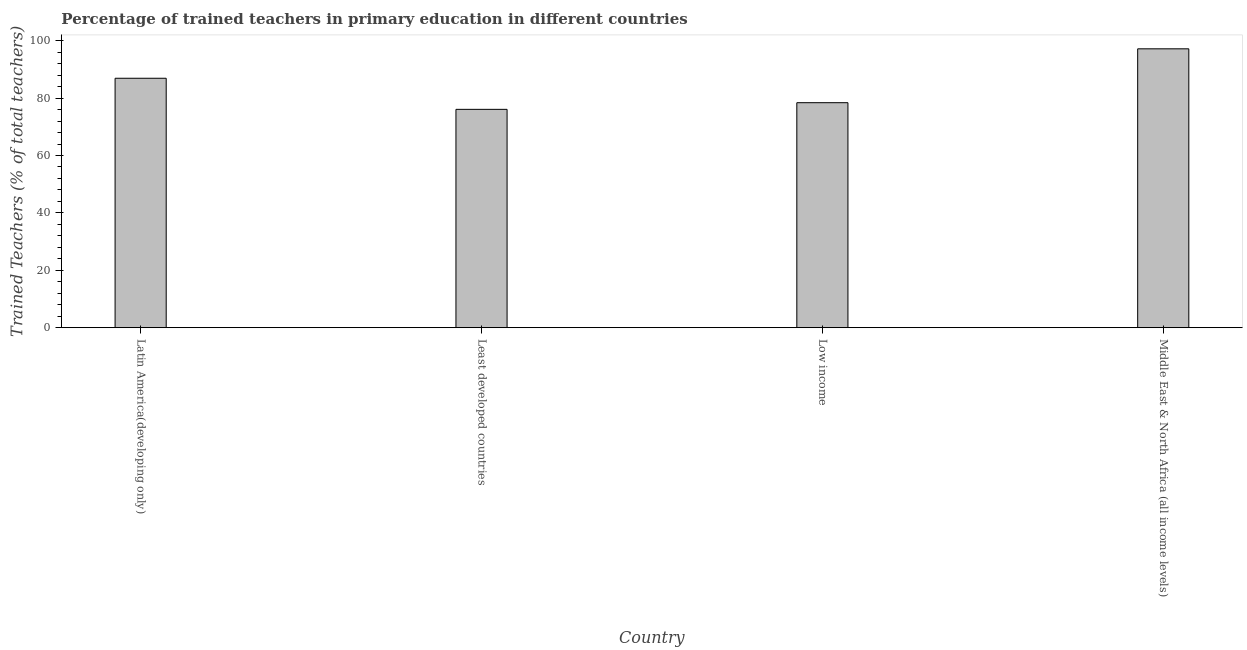Does the graph contain grids?
Offer a terse response. No. What is the title of the graph?
Your response must be concise. Percentage of trained teachers in primary education in different countries. What is the label or title of the Y-axis?
Your answer should be very brief. Trained Teachers (% of total teachers). What is the percentage of trained teachers in Latin America(developing only)?
Make the answer very short. 86.92. Across all countries, what is the maximum percentage of trained teachers?
Your answer should be very brief. 97.18. Across all countries, what is the minimum percentage of trained teachers?
Your response must be concise. 76.09. In which country was the percentage of trained teachers maximum?
Offer a terse response. Middle East & North Africa (all income levels). In which country was the percentage of trained teachers minimum?
Your answer should be very brief. Least developed countries. What is the sum of the percentage of trained teachers?
Your answer should be compact. 338.6. What is the difference between the percentage of trained teachers in Latin America(developing only) and Least developed countries?
Offer a very short reply. 10.84. What is the average percentage of trained teachers per country?
Offer a terse response. 84.65. What is the median percentage of trained teachers?
Provide a succinct answer. 82.66. In how many countries, is the percentage of trained teachers greater than 32 %?
Keep it short and to the point. 4. What is the ratio of the percentage of trained teachers in Latin America(developing only) to that in Middle East & North Africa (all income levels)?
Your response must be concise. 0.89. What is the difference between the highest and the second highest percentage of trained teachers?
Offer a very short reply. 10.26. Is the sum of the percentage of trained teachers in Least developed countries and Low income greater than the maximum percentage of trained teachers across all countries?
Offer a terse response. Yes. What is the difference between the highest and the lowest percentage of trained teachers?
Provide a succinct answer. 21.1. How many bars are there?
Offer a terse response. 4. How many countries are there in the graph?
Your answer should be very brief. 4. What is the Trained Teachers (% of total teachers) in Latin America(developing only)?
Your answer should be very brief. 86.92. What is the Trained Teachers (% of total teachers) in Least developed countries?
Your answer should be compact. 76.09. What is the Trained Teachers (% of total teachers) in Low income?
Offer a very short reply. 78.41. What is the Trained Teachers (% of total teachers) of Middle East & North Africa (all income levels)?
Offer a terse response. 97.18. What is the difference between the Trained Teachers (% of total teachers) in Latin America(developing only) and Least developed countries?
Keep it short and to the point. 10.84. What is the difference between the Trained Teachers (% of total teachers) in Latin America(developing only) and Low income?
Make the answer very short. 8.52. What is the difference between the Trained Teachers (% of total teachers) in Latin America(developing only) and Middle East & North Africa (all income levels)?
Offer a very short reply. -10.26. What is the difference between the Trained Teachers (% of total teachers) in Least developed countries and Low income?
Offer a terse response. -2.32. What is the difference between the Trained Teachers (% of total teachers) in Least developed countries and Middle East & North Africa (all income levels)?
Ensure brevity in your answer.  -21.1. What is the difference between the Trained Teachers (% of total teachers) in Low income and Middle East & North Africa (all income levels)?
Your answer should be very brief. -18.78. What is the ratio of the Trained Teachers (% of total teachers) in Latin America(developing only) to that in Least developed countries?
Offer a very short reply. 1.14. What is the ratio of the Trained Teachers (% of total teachers) in Latin America(developing only) to that in Low income?
Give a very brief answer. 1.11. What is the ratio of the Trained Teachers (% of total teachers) in Latin America(developing only) to that in Middle East & North Africa (all income levels)?
Give a very brief answer. 0.89. What is the ratio of the Trained Teachers (% of total teachers) in Least developed countries to that in Low income?
Your answer should be very brief. 0.97. What is the ratio of the Trained Teachers (% of total teachers) in Least developed countries to that in Middle East & North Africa (all income levels)?
Your response must be concise. 0.78. What is the ratio of the Trained Teachers (% of total teachers) in Low income to that in Middle East & North Africa (all income levels)?
Your answer should be very brief. 0.81. 